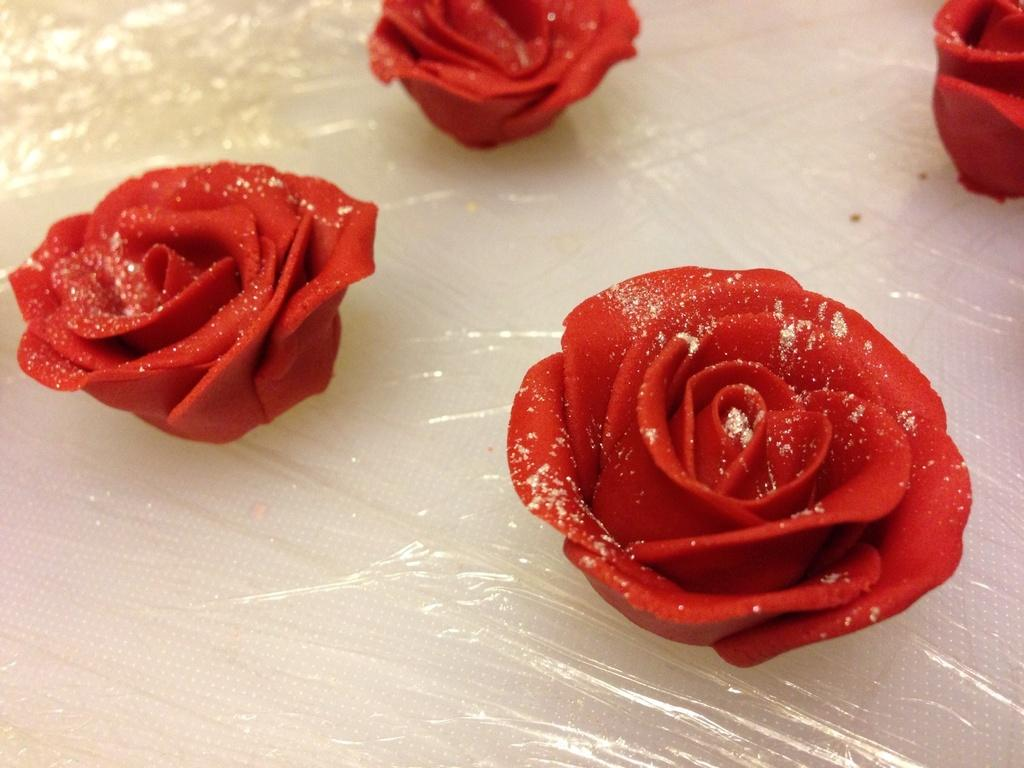What type of flowers are in the image? There are red roses in the image. Where are the red roses placed? The red roses are on a plastic cover. What is at the bottom of the image? There is white color cloth or tissue paper at the bottom of the image. What does the moon have to do with respect in the image? The moon is not present in the image, and therefore it cannot be associated with respect or any other concept in this context. 